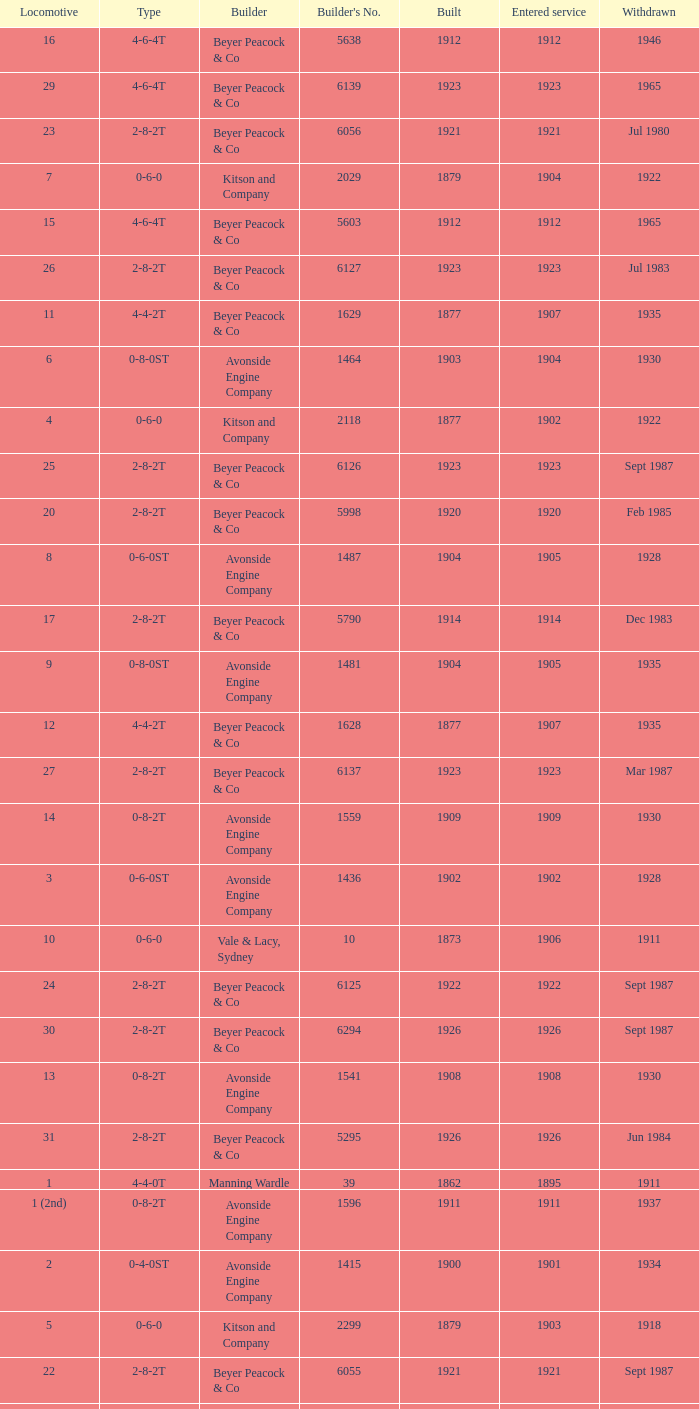How many years entered service when there were 13 locomotives? 1.0. 